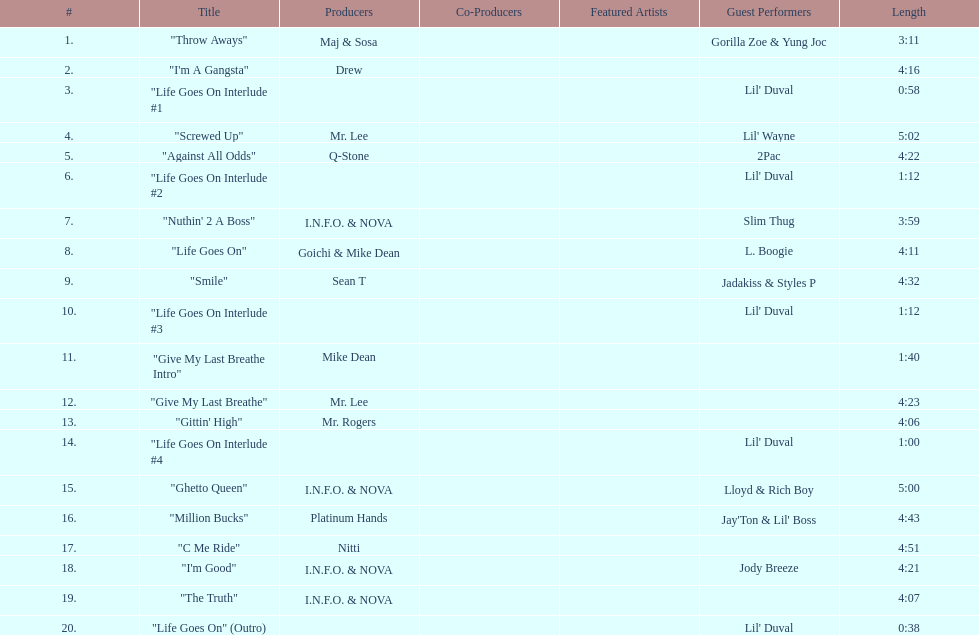Which tracks feature the same producer(s) in consecutive order on this album? "I'm Good", "The Truth". 